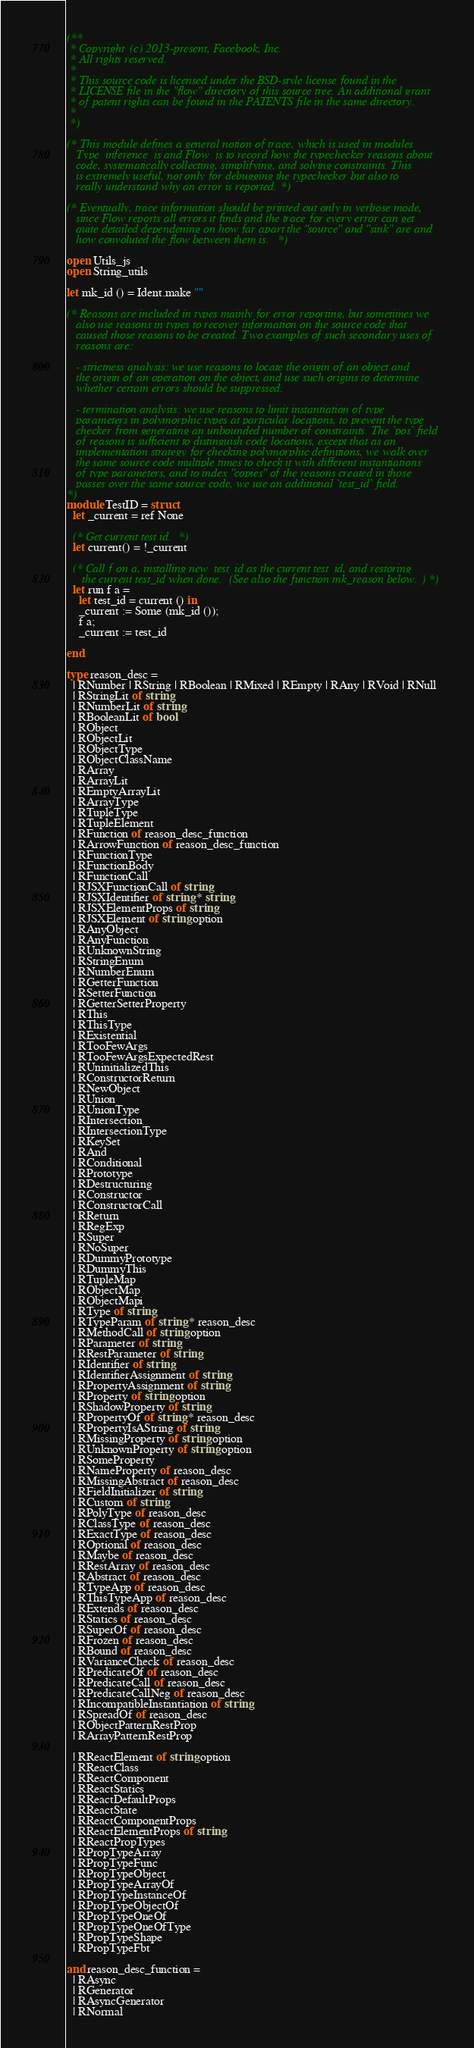<code> <loc_0><loc_0><loc_500><loc_500><_OCaml_>(**
 * Copyright (c) 2013-present, Facebook, Inc.
 * All rights reserved.
 *
 * This source code is licensed under the BSD-style license found in the
 * LICENSE file in the "flow" directory of this source tree. An additional grant
 * of patent rights can be found in the PATENTS file in the same directory.
 *
 *)

(* This module defines a general notion of trace, which is used in modules
   Type_inference_js and Flow_js to record how the typechecker reasons about
   code, systematically collecting, simplifying, and solving constraints. This
   is extremely useful, not only for debugging the typechecker but also to
   really understand why an error is reported. *)

(* Eventually, trace information should be printed out only in verbose mode,
   since Flow reports all errors it finds and the trace for every error can get
   quite detailed dependening on how far apart the "source" and "sink" are and
   how convoluted the flow between them is. *)

open Utils_js
open String_utils

let mk_id () = Ident.make ""

(* Reasons are included in types mainly for error reporting, but sometimes we
   also use reasons in types to recover information on the source code that
   caused those reasons to be created. Two examples of such secondary uses of
   reasons are:

   - strictness analysis: we use reasons to locate the origin of an object and
   the origin of an operation on the object, and use such origins to determine
   whether certain errors should be suppressed.

   - termination analysis: we use reasons to limit instantiation of type
   parameters in polymorphic types at particular locations, to prevent the type
   checker from generating an unbounded number of constraints. The `pos` field
   of reasons is sufficient to distinguish code locations, except that as an
   implementation strategy for checking polymorphic definitions, we walk over
   the same source code multiple times to check it with different instantiations
   of type parameters, and to index "copies" of the reasons created in those
   passes over the same source code, we use an additional `test_id` field.
*)
module TestID = struct
  let _current = ref None

  (* Get current test id. *)
  let current() = !_current

  (* Call f on a, installing new_test_id as the current test_id, and restoring
     the current test_id when done. (See also the function mk_reason below.) *)
  let run f a =
    let test_id = current () in
    _current := Some (mk_id ());
    f a;
    _current := test_id

end

type reason_desc =
  | RNumber | RString | RBoolean | RMixed | REmpty | RAny | RVoid | RNull
  | RStringLit of string
  | RNumberLit of string
  | RBooleanLit of bool
  | RObject
  | RObjectLit
  | RObjectType
  | RObjectClassName
  | RArray
  | RArrayLit
  | REmptyArrayLit
  | RArrayType
  | RTupleType
  | RTupleElement
  | RFunction of reason_desc_function
  | RArrowFunction of reason_desc_function
  | RFunctionType
  | RFunctionBody
  | RFunctionCall
  | RJSXFunctionCall of string
  | RJSXIdentifier of string * string
  | RJSXElementProps of string
  | RJSXElement of string option
  | RAnyObject
  | RAnyFunction
  | RUnknownString
  | RStringEnum
  | RNumberEnum
  | RGetterFunction
  | RSetterFunction
  | RGetterSetterProperty
  | RThis
  | RThisType
  | RExistential
  | RTooFewArgs
  | RTooFewArgsExpectedRest
  | RUninitializedThis
  | RConstructorReturn
  | RNewObject
  | RUnion
  | RUnionType
  | RIntersection
  | RIntersectionType
  | RKeySet
  | RAnd
  | RConditional
  | RPrototype
  | RDestructuring
  | RConstructor
  | RConstructorCall
  | RReturn
  | RRegExp
  | RSuper
  | RNoSuper
  | RDummyPrototype
  | RDummyThis
  | RTupleMap
  | RObjectMap
  | RObjectMapi
  | RType of string
  | RTypeParam of string * reason_desc
  | RMethodCall of string option
  | RParameter of string
  | RRestParameter of string
  | RIdentifier of string
  | RIdentifierAssignment of string
  | RPropertyAssignment of string
  | RProperty of string option
  | RShadowProperty of string
  | RPropertyOf of string * reason_desc
  | RPropertyIsAString of string
  | RMissingProperty of string option
  | RUnknownProperty of string option
  | RSomeProperty
  | RNameProperty of reason_desc
  | RMissingAbstract of reason_desc
  | RFieldInitializer of string
  | RCustom of string
  | RPolyType of reason_desc
  | RClassType of reason_desc
  | RExactType of reason_desc
  | ROptional of reason_desc
  | RMaybe of reason_desc
  | RRestArray of reason_desc
  | RAbstract of reason_desc
  | RTypeApp of reason_desc
  | RThisTypeApp of reason_desc
  | RExtends of reason_desc
  | RStatics of reason_desc
  | RSuperOf of reason_desc
  | RFrozen of reason_desc
  | RBound of reason_desc
  | RVarianceCheck of reason_desc
  | RPredicateOf of reason_desc
  | RPredicateCall of reason_desc
  | RPredicateCallNeg of reason_desc
  | RIncompatibleInstantiation of string
  | RSpreadOf of reason_desc
  | RObjectPatternRestProp
  | RArrayPatternRestProp

  | RReactElement of string option
  | RReactClass
  | RReactComponent
  | RReactStatics
  | RReactDefaultProps
  | RReactState
  | RReactComponentProps
  | RReactElementProps of string
  | RReactPropTypes
  | RPropTypeArray
  | RPropTypeFunc
  | RPropTypeObject
  | RPropTypeArrayOf
  | RPropTypeInstanceOf
  | RPropTypeObjectOf
  | RPropTypeOneOf
  | RPropTypeOneOfType
  | RPropTypeShape
  | RPropTypeFbt

and reason_desc_function =
  | RAsync
  | RGenerator
  | RAsyncGenerator
  | RNormal
</code> 